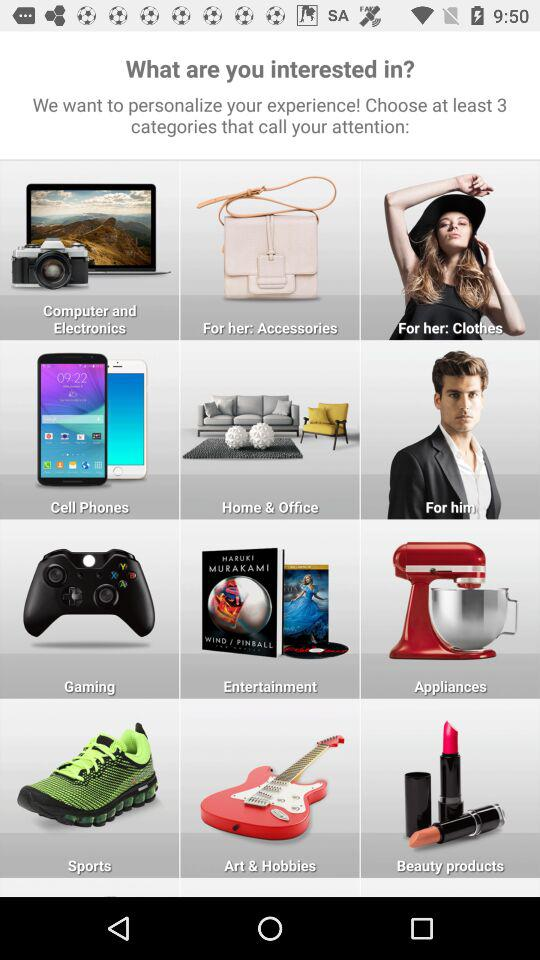How many categories are related to clothing?
Answer the question using a single word or phrase. 2 